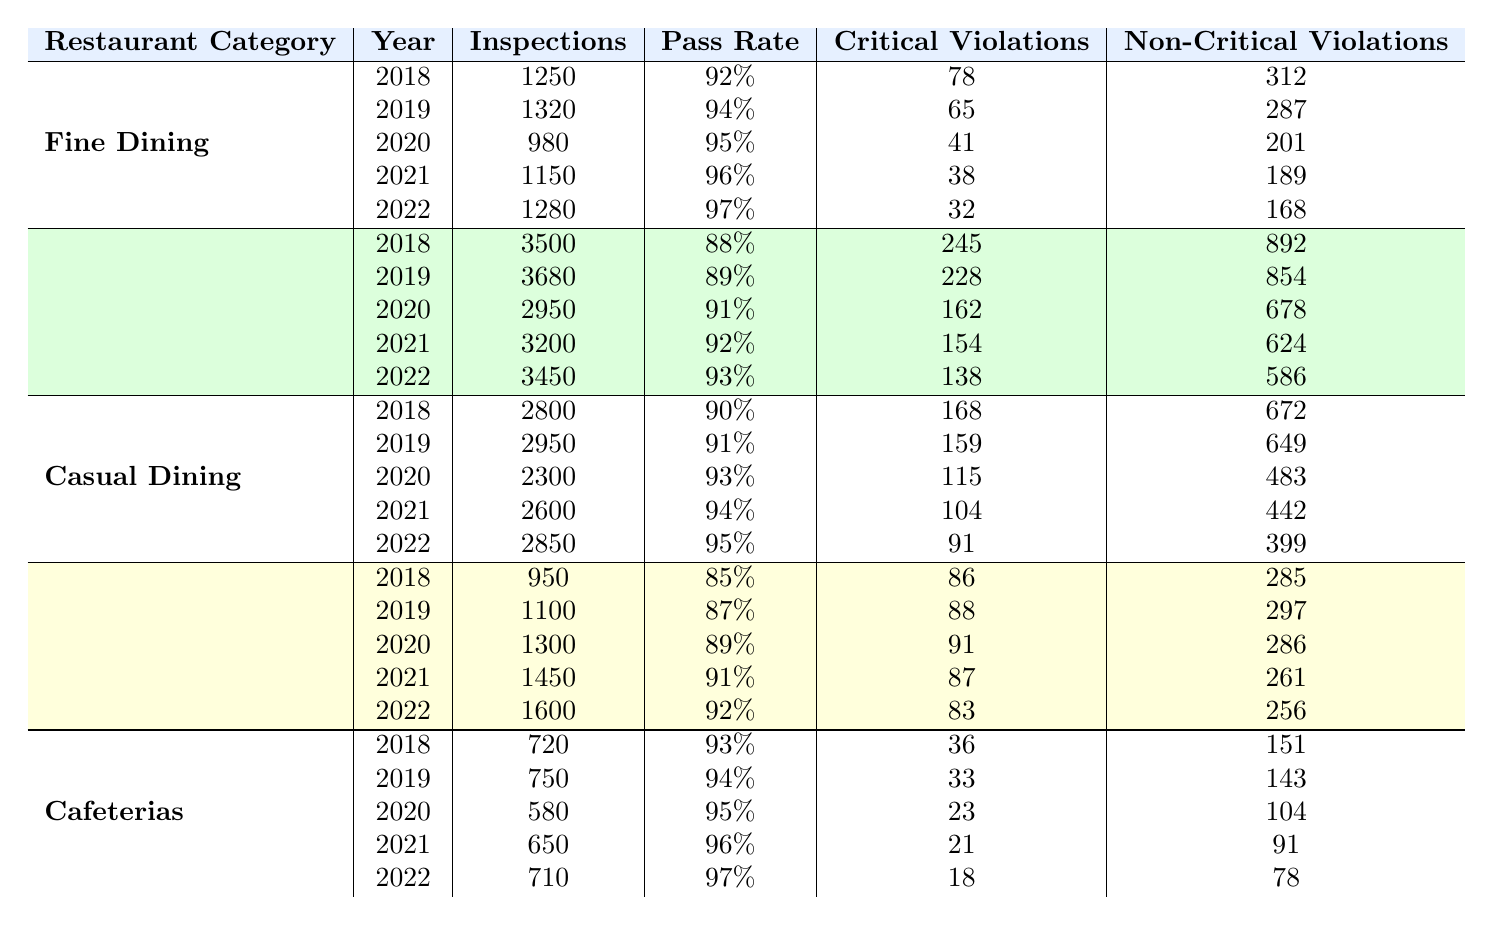What was the pass rate for Fine Dining restaurants in 2020? The table shows that in 2020, the pass rate for Fine Dining restaurants was 95%.
Answer: 95% How many inspections were conducted for Casual Dining in 2022? Referring to the table, in 2022, there were 2850 inspections conducted for Casual Dining.
Answer: 2850 What is the total number of critical violations recorded for Fast Food restaurants over the 5 years? To find the total, sum the critical violations from each year: 245 + 228 + 162 + 154 + 138 = 927.
Answer: 927 Did Food Trucks have a higher pass rate in 2021 than in 2020? The pass rate for Food Trucks was 91% in 2021 and 89% in 2020, so yes, 2021 was higher.
Answer: Yes Which restaurant category had the lowest critical violations in 2022? By comparing the critical violations for each category in 2022, Cafeterias had the lowest with 18 violations.
Answer: Cafeterias What was the difference in pass rates between Fast Food in 2018 and 2022? The pass rate in 2018 was 88% and in 2022 was 93%. The difference is 93% - 88% = 5%.
Answer: 5% Which restaurant category showed the most improvement in pass rate from 2018 to 2022? Checking the pass rates: Fine Dining (92% to 97%) improved by 5%, Fast Food (88% to 93%) by 5%, Casual Dining (90% to 95%) by 5%, Food Trucks (85% to 92%) by 7%, and Cafeterias (93% to 97%) by 4%. Food Trucks had the most improvement with 7%.
Answer: Food Trucks What is the average number of inspections conducted per year for Cafeterias over the 5 years? The total inspections conducted: 720 + 750 + 580 + 650 + 710 = 3410. Dividing by 5 gives an average of 3410 / 5 = 682.
Answer: 682 How do the non-critical violations for Casual Dining in 2020 compare to Fine Dining in 2022? Casual Dining had 483 non-critical violations in 2020 while Fine Dining had 168 in 2022. Hence, Casual Dining had more non-critical violations with 483 > 168.
Answer: More for Casual Dining Which restaurant category had the most inspections conducted in 2021? The table shows Fast Food had 3200 inspections in 2021, which is more than any other category.
Answer: Fast Food 